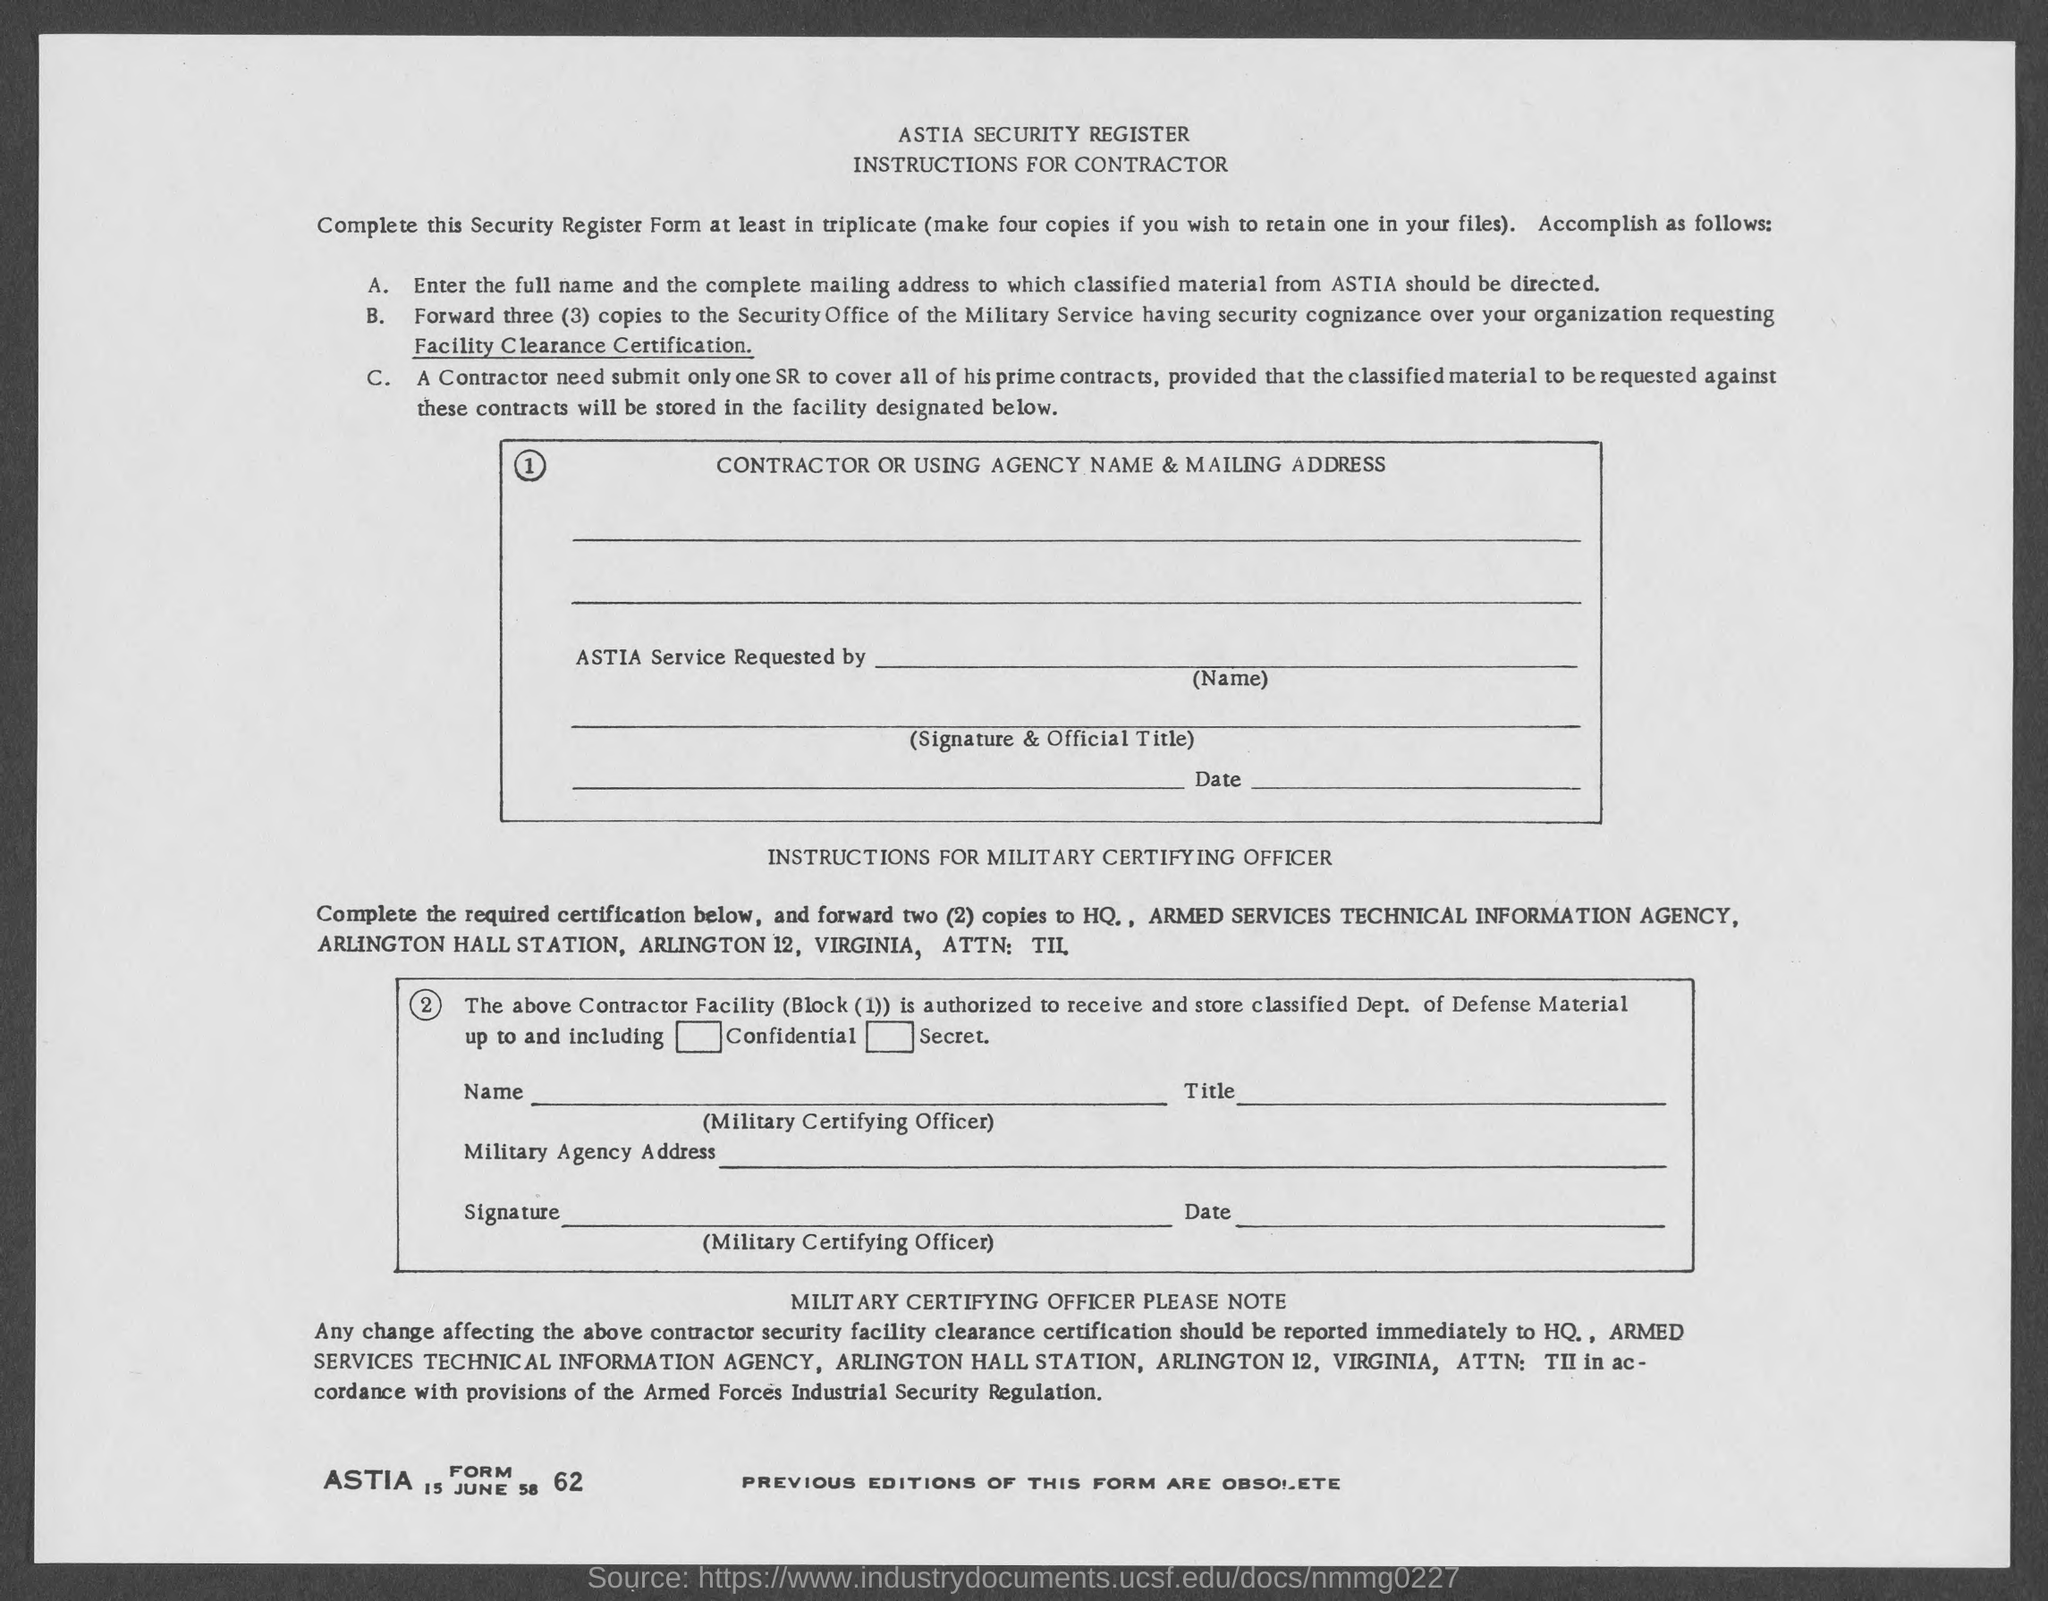Specify some key components in this picture. The date mentioned in the form is June 15, 58. I request the ASTIA Form No. 62... 